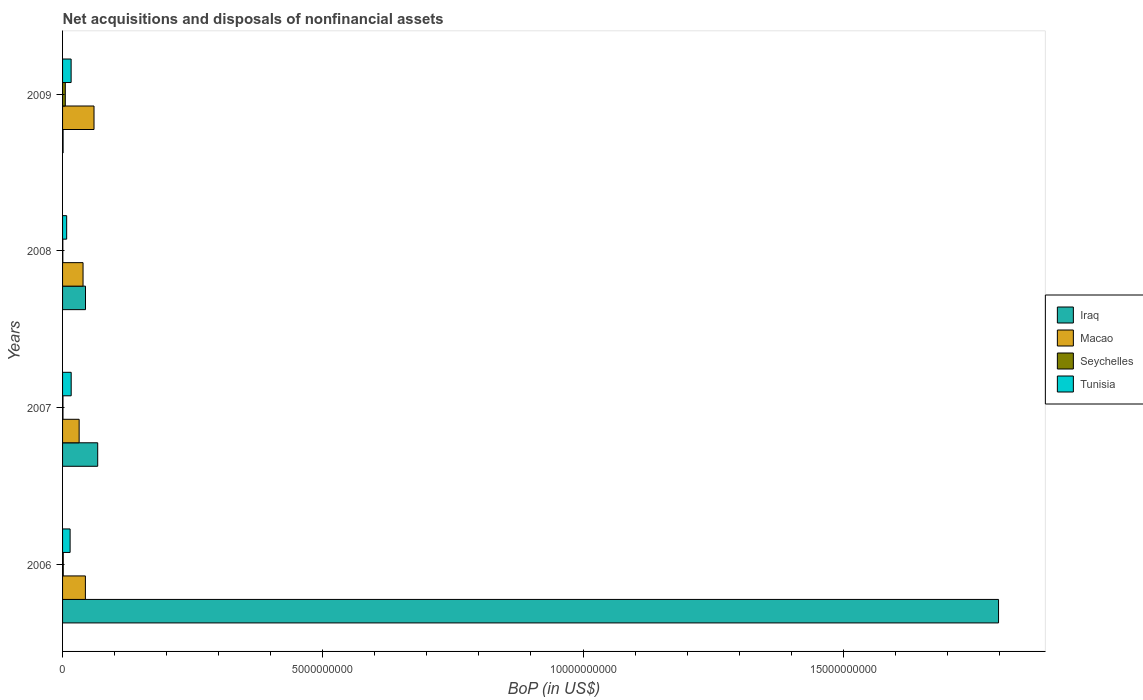Are the number of bars per tick equal to the number of legend labels?
Your response must be concise. Yes. How many bars are there on the 2nd tick from the top?
Offer a very short reply. 4. How many bars are there on the 3rd tick from the bottom?
Your answer should be very brief. 4. What is the label of the 1st group of bars from the top?
Offer a very short reply. 2009. In how many cases, is the number of bars for a given year not equal to the number of legend labels?
Provide a short and direct response. 0. What is the Balance of Payments in Macao in 2009?
Give a very brief answer. 6.04e+08. Across all years, what is the maximum Balance of Payments in Iraq?
Keep it short and to the point. 1.80e+1. Across all years, what is the minimum Balance of Payments in Iraq?
Your answer should be very brief. 1.02e+07. In which year was the Balance of Payments in Macao maximum?
Your answer should be very brief. 2009. In which year was the Balance of Payments in Iraq minimum?
Offer a terse response. 2009. What is the total Balance of Payments in Tunisia in the graph?
Offer a terse response. 5.54e+08. What is the difference between the Balance of Payments in Iraq in 2007 and that in 2009?
Make the answer very short. 6.65e+08. What is the difference between the Balance of Payments in Tunisia in 2009 and the Balance of Payments in Seychelles in 2008?
Offer a very short reply. 1.59e+08. What is the average Balance of Payments in Iraq per year?
Give a very brief answer. 4.78e+09. In the year 2006, what is the difference between the Balance of Payments in Seychelles and Balance of Payments in Iraq?
Make the answer very short. -1.80e+1. In how many years, is the Balance of Payments in Tunisia greater than 11000000000 US$?
Your answer should be compact. 0. What is the ratio of the Balance of Payments in Macao in 2006 to that in 2007?
Keep it short and to the point. 1.38. Is the difference between the Balance of Payments in Seychelles in 2008 and 2009 greater than the difference between the Balance of Payments in Iraq in 2008 and 2009?
Offer a very short reply. No. What is the difference between the highest and the second highest Balance of Payments in Macao?
Keep it short and to the point. 1.66e+08. What is the difference between the highest and the lowest Balance of Payments in Macao?
Your answer should be very brief. 2.86e+08. Is it the case that in every year, the sum of the Balance of Payments in Seychelles and Balance of Payments in Tunisia is greater than the sum of Balance of Payments in Macao and Balance of Payments in Iraq?
Offer a very short reply. No. What does the 3rd bar from the top in 2007 represents?
Offer a terse response. Macao. What does the 3rd bar from the bottom in 2007 represents?
Ensure brevity in your answer.  Seychelles. Is it the case that in every year, the sum of the Balance of Payments in Seychelles and Balance of Payments in Tunisia is greater than the Balance of Payments in Iraq?
Give a very brief answer. No. Are all the bars in the graph horizontal?
Your response must be concise. Yes. What is the difference between two consecutive major ticks on the X-axis?
Offer a very short reply. 5.00e+09. Does the graph contain grids?
Ensure brevity in your answer.  No. Where does the legend appear in the graph?
Your answer should be compact. Center right. How many legend labels are there?
Make the answer very short. 4. How are the legend labels stacked?
Give a very brief answer. Vertical. What is the title of the graph?
Give a very brief answer. Net acquisitions and disposals of nonfinancial assets. What is the label or title of the X-axis?
Keep it short and to the point. BoP (in US$). What is the label or title of the Y-axis?
Offer a very short reply. Years. What is the BoP (in US$) of Iraq in 2006?
Your response must be concise. 1.80e+1. What is the BoP (in US$) in Macao in 2006?
Offer a very short reply. 4.38e+08. What is the BoP (in US$) of Seychelles in 2006?
Ensure brevity in your answer.  1.32e+07. What is the BoP (in US$) of Tunisia in 2006?
Make the answer very short. 1.45e+08. What is the BoP (in US$) of Iraq in 2007?
Provide a succinct answer. 6.75e+08. What is the BoP (in US$) of Macao in 2007?
Offer a terse response. 3.19e+08. What is the BoP (in US$) in Seychelles in 2007?
Give a very brief answer. 8.17e+06. What is the BoP (in US$) in Tunisia in 2007?
Your answer should be compact. 1.66e+08. What is the BoP (in US$) of Iraq in 2008?
Give a very brief answer. 4.41e+08. What is the BoP (in US$) of Macao in 2008?
Provide a succinct answer. 3.93e+08. What is the BoP (in US$) of Seychelles in 2008?
Your answer should be compact. 5.04e+06. What is the BoP (in US$) in Tunisia in 2008?
Your response must be concise. 7.89e+07. What is the BoP (in US$) in Iraq in 2009?
Provide a short and direct response. 1.02e+07. What is the BoP (in US$) of Macao in 2009?
Your answer should be very brief. 6.04e+08. What is the BoP (in US$) in Seychelles in 2009?
Provide a succinct answer. 5.25e+07. What is the BoP (in US$) in Tunisia in 2009?
Your response must be concise. 1.64e+08. Across all years, what is the maximum BoP (in US$) in Iraq?
Offer a terse response. 1.80e+1. Across all years, what is the maximum BoP (in US$) in Macao?
Your answer should be compact. 6.04e+08. Across all years, what is the maximum BoP (in US$) in Seychelles?
Your answer should be compact. 5.25e+07. Across all years, what is the maximum BoP (in US$) in Tunisia?
Provide a short and direct response. 1.66e+08. Across all years, what is the minimum BoP (in US$) in Iraq?
Your response must be concise. 1.02e+07. Across all years, what is the minimum BoP (in US$) in Macao?
Offer a very short reply. 3.19e+08. Across all years, what is the minimum BoP (in US$) of Seychelles?
Offer a terse response. 5.04e+06. Across all years, what is the minimum BoP (in US$) in Tunisia?
Offer a very short reply. 7.89e+07. What is the total BoP (in US$) of Iraq in the graph?
Make the answer very short. 1.91e+1. What is the total BoP (in US$) in Macao in the graph?
Keep it short and to the point. 1.75e+09. What is the total BoP (in US$) of Seychelles in the graph?
Your answer should be compact. 7.89e+07. What is the total BoP (in US$) of Tunisia in the graph?
Offer a terse response. 5.54e+08. What is the difference between the BoP (in US$) in Iraq in 2006 and that in 2007?
Ensure brevity in your answer.  1.73e+1. What is the difference between the BoP (in US$) in Macao in 2006 and that in 2007?
Provide a short and direct response. 1.20e+08. What is the difference between the BoP (in US$) in Seychelles in 2006 and that in 2007?
Offer a very short reply. 5.07e+06. What is the difference between the BoP (in US$) in Tunisia in 2006 and that in 2007?
Your answer should be very brief. -2.06e+07. What is the difference between the BoP (in US$) of Iraq in 2006 and that in 2008?
Your answer should be very brief. 1.75e+1. What is the difference between the BoP (in US$) in Macao in 2006 and that in 2008?
Your answer should be very brief. 4.50e+07. What is the difference between the BoP (in US$) in Seychelles in 2006 and that in 2008?
Your answer should be very brief. 8.20e+06. What is the difference between the BoP (in US$) in Tunisia in 2006 and that in 2008?
Your answer should be compact. 6.60e+07. What is the difference between the BoP (in US$) in Iraq in 2006 and that in 2009?
Your response must be concise. 1.80e+1. What is the difference between the BoP (in US$) of Macao in 2006 and that in 2009?
Provide a short and direct response. -1.66e+08. What is the difference between the BoP (in US$) in Seychelles in 2006 and that in 2009?
Make the answer very short. -3.92e+07. What is the difference between the BoP (in US$) of Tunisia in 2006 and that in 2009?
Your response must be concise. -1.96e+07. What is the difference between the BoP (in US$) of Iraq in 2007 and that in 2008?
Ensure brevity in your answer.  2.34e+08. What is the difference between the BoP (in US$) of Macao in 2007 and that in 2008?
Your response must be concise. -7.49e+07. What is the difference between the BoP (in US$) in Seychelles in 2007 and that in 2008?
Offer a terse response. 3.13e+06. What is the difference between the BoP (in US$) of Tunisia in 2007 and that in 2008?
Your answer should be very brief. 8.66e+07. What is the difference between the BoP (in US$) in Iraq in 2007 and that in 2009?
Keep it short and to the point. 6.65e+08. What is the difference between the BoP (in US$) of Macao in 2007 and that in 2009?
Provide a short and direct response. -2.86e+08. What is the difference between the BoP (in US$) of Seychelles in 2007 and that in 2009?
Your answer should be compact. -4.43e+07. What is the difference between the BoP (in US$) of Tunisia in 2007 and that in 2009?
Offer a very short reply. 1.04e+06. What is the difference between the BoP (in US$) in Iraq in 2008 and that in 2009?
Ensure brevity in your answer.  4.31e+08. What is the difference between the BoP (in US$) in Macao in 2008 and that in 2009?
Keep it short and to the point. -2.11e+08. What is the difference between the BoP (in US$) of Seychelles in 2008 and that in 2009?
Provide a succinct answer. -4.74e+07. What is the difference between the BoP (in US$) of Tunisia in 2008 and that in 2009?
Your response must be concise. -8.56e+07. What is the difference between the BoP (in US$) of Iraq in 2006 and the BoP (in US$) of Macao in 2007?
Offer a terse response. 1.77e+1. What is the difference between the BoP (in US$) in Iraq in 2006 and the BoP (in US$) in Seychelles in 2007?
Your answer should be compact. 1.80e+1. What is the difference between the BoP (in US$) in Iraq in 2006 and the BoP (in US$) in Tunisia in 2007?
Offer a very short reply. 1.78e+1. What is the difference between the BoP (in US$) in Macao in 2006 and the BoP (in US$) in Seychelles in 2007?
Your response must be concise. 4.30e+08. What is the difference between the BoP (in US$) of Macao in 2006 and the BoP (in US$) of Tunisia in 2007?
Keep it short and to the point. 2.73e+08. What is the difference between the BoP (in US$) of Seychelles in 2006 and the BoP (in US$) of Tunisia in 2007?
Offer a very short reply. -1.52e+08. What is the difference between the BoP (in US$) of Iraq in 2006 and the BoP (in US$) of Macao in 2008?
Make the answer very short. 1.76e+1. What is the difference between the BoP (in US$) in Iraq in 2006 and the BoP (in US$) in Seychelles in 2008?
Your answer should be very brief. 1.80e+1. What is the difference between the BoP (in US$) of Iraq in 2006 and the BoP (in US$) of Tunisia in 2008?
Provide a succinct answer. 1.79e+1. What is the difference between the BoP (in US$) in Macao in 2006 and the BoP (in US$) in Seychelles in 2008?
Give a very brief answer. 4.33e+08. What is the difference between the BoP (in US$) in Macao in 2006 and the BoP (in US$) in Tunisia in 2008?
Provide a succinct answer. 3.60e+08. What is the difference between the BoP (in US$) of Seychelles in 2006 and the BoP (in US$) of Tunisia in 2008?
Give a very brief answer. -6.56e+07. What is the difference between the BoP (in US$) of Iraq in 2006 and the BoP (in US$) of Macao in 2009?
Offer a terse response. 1.74e+1. What is the difference between the BoP (in US$) of Iraq in 2006 and the BoP (in US$) of Seychelles in 2009?
Keep it short and to the point. 1.79e+1. What is the difference between the BoP (in US$) of Iraq in 2006 and the BoP (in US$) of Tunisia in 2009?
Offer a terse response. 1.78e+1. What is the difference between the BoP (in US$) of Macao in 2006 and the BoP (in US$) of Seychelles in 2009?
Your answer should be compact. 3.86e+08. What is the difference between the BoP (in US$) in Macao in 2006 and the BoP (in US$) in Tunisia in 2009?
Make the answer very short. 2.74e+08. What is the difference between the BoP (in US$) in Seychelles in 2006 and the BoP (in US$) in Tunisia in 2009?
Your answer should be compact. -1.51e+08. What is the difference between the BoP (in US$) of Iraq in 2007 and the BoP (in US$) of Macao in 2008?
Offer a very short reply. 2.82e+08. What is the difference between the BoP (in US$) of Iraq in 2007 and the BoP (in US$) of Seychelles in 2008?
Your answer should be very brief. 6.70e+08. What is the difference between the BoP (in US$) in Iraq in 2007 and the BoP (in US$) in Tunisia in 2008?
Your answer should be compact. 5.96e+08. What is the difference between the BoP (in US$) of Macao in 2007 and the BoP (in US$) of Seychelles in 2008?
Make the answer very short. 3.14e+08. What is the difference between the BoP (in US$) in Macao in 2007 and the BoP (in US$) in Tunisia in 2008?
Provide a succinct answer. 2.40e+08. What is the difference between the BoP (in US$) of Seychelles in 2007 and the BoP (in US$) of Tunisia in 2008?
Make the answer very short. -7.07e+07. What is the difference between the BoP (in US$) in Iraq in 2007 and the BoP (in US$) in Macao in 2009?
Offer a very short reply. 7.09e+07. What is the difference between the BoP (in US$) in Iraq in 2007 and the BoP (in US$) in Seychelles in 2009?
Your response must be concise. 6.23e+08. What is the difference between the BoP (in US$) in Iraq in 2007 and the BoP (in US$) in Tunisia in 2009?
Offer a very short reply. 5.11e+08. What is the difference between the BoP (in US$) of Macao in 2007 and the BoP (in US$) of Seychelles in 2009?
Your response must be concise. 2.66e+08. What is the difference between the BoP (in US$) in Macao in 2007 and the BoP (in US$) in Tunisia in 2009?
Keep it short and to the point. 1.54e+08. What is the difference between the BoP (in US$) in Seychelles in 2007 and the BoP (in US$) in Tunisia in 2009?
Ensure brevity in your answer.  -1.56e+08. What is the difference between the BoP (in US$) in Iraq in 2008 and the BoP (in US$) in Macao in 2009?
Offer a very short reply. -1.63e+08. What is the difference between the BoP (in US$) of Iraq in 2008 and the BoP (in US$) of Seychelles in 2009?
Give a very brief answer. 3.88e+08. What is the difference between the BoP (in US$) of Iraq in 2008 and the BoP (in US$) of Tunisia in 2009?
Provide a succinct answer. 2.76e+08. What is the difference between the BoP (in US$) of Macao in 2008 and the BoP (in US$) of Seychelles in 2009?
Your response must be concise. 3.41e+08. What is the difference between the BoP (in US$) in Macao in 2008 and the BoP (in US$) in Tunisia in 2009?
Give a very brief answer. 2.29e+08. What is the difference between the BoP (in US$) in Seychelles in 2008 and the BoP (in US$) in Tunisia in 2009?
Ensure brevity in your answer.  -1.59e+08. What is the average BoP (in US$) in Iraq per year?
Keep it short and to the point. 4.78e+09. What is the average BoP (in US$) in Macao per year?
Ensure brevity in your answer.  4.39e+08. What is the average BoP (in US$) in Seychelles per year?
Provide a short and direct response. 1.97e+07. What is the average BoP (in US$) of Tunisia per year?
Your answer should be compact. 1.38e+08. In the year 2006, what is the difference between the BoP (in US$) in Iraq and BoP (in US$) in Macao?
Provide a succinct answer. 1.75e+1. In the year 2006, what is the difference between the BoP (in US$) of Iraq and BoP (in US$) of Seychelles?
Your response must be concise. 1.80e+1. In the year 2006, what is the difference between the BoP (in US$) in Iraq and BoP (in US$) in Tunisia?
Your response must be concise. 1.78e+1. In the year 2006, what is the difference between the BoP (in US$) of Macao and BoP (in US$) of Seychelles?
Your response must be concise. 4.25e+08. In the year 2006, what is the difference between the BoP (in US$) of Macao and BoP (in US$) of Tunisia?
Provide a succinct answer. 2.94e+08. In the year 2006, what is the difference between the BoP (in US$) of Seychelles and BoP (in US$) of Tunisia?
Make the answer very short. -1.32e+08. In the year 2007, what is the difference between the BoP (in US$) in Iraq and BoP (in US$) in Macao?
Keep it short and to the point. 3.56e+08. In the year 2007, what is the difference between the BoP (in US$) of Iraq and BoP (in US$) of Seychelles?
Your answer should be very brief. 6.67e+08. In the year 2007, what is the difference between the BoP (in US$) of Iraq and BoP (in US$) of Tunisia?
Ensure brevity in your answer.  5.10e+08. In the year 2007, what is the difference between the BoP (in US$) of Macao and BoP (in US$) of Seychelles?
Your response must be concise. 3.10e+08. In the year 2007, what is the difference between the BoP (in US$) in Macao and BoP (in US$) in Tunisia?
Your response must be concise. 1.53e+08. In the year 2007, what is the difference between the BoP (in US$) in Seychelles and BoP (in US$) in Tunisia?
Make the answer very short. -1.57e+08. In the year 2008, what is the difference between the BoP (in US$) in Iraq and BoP (in US$) in Macao?
Your answer should be compact. 4.73e+07. In the year 2008, what is the difference between the BoP (in US$) of Iraq and BoP (in US$) of Seychelles?
Keep it short and to the point. 4.36e+08. In the year 2008, what is the difference between the BoP (in US$) of Iraq and BoP (in US$) of Tunisia?
Make the answer very short. 3.62e+08. In the year 2008, what is the difference between the BoP (in US$) of Macao and BoP (in US$) of Seychelles?
Your answer should be very brief. 3.88e+08. In the year 2008, what is the difference between the BoP (in US$) in Macao and BoP (in US$) in Tunisia?
Keep it short and to the point. 3.15e+08. In the year 2008, what is the difference between the BoP (in US$) in Seychelles and BoP (in US$) in Tunisia?
Your answer should be compact. -7.38e+07. In the year 2009, what is the difference between the BoP (in US$) in Iraq and BoP (in US$) in Macao?
Provide a succinct answer. -5.94e+08. In the year 2009, what is the difference between the BoP (in US$) in Iraq and BoP (in US$) in Seychelles?
Make the answer very short. -4.23e+07. In the year 2009, what is the difference between the BoP (in US$) in Iraq and BoP (in US$) in Tunisia?
Provide a succinct answer. -1.54e+08. In the year 2009, what is the difference between the BoP (in US$) of Macao and BoP (in US$) of Seychelles?
Your answer should be compact. 5.52e+08. In the year 2009, what is the difference between the BoP (in US$) of Macao and BoP (in US$) of Tunisia?
Provide a succinct answer. 4.40e+08. In the year 2009, what is the difference between the BoP (in US$) of Seychelles and BoP (in US$) of Tunisia?
Your response must be concise. -1.12e+08. What is the ratio of the BoP (in US$) of Iraq in 2006 to that in 2007?
Provide a succinct answer. 26.64. What is the ratio of the BoP (in US$) in Macao in 2006 to that in 2007?
Your answer should be very brief. 1.38. What is the ratio of the BoP (in US$) of Seychelles in 2006 to that in 2007?
Keep it short and to the point. 1.62. What is the ratio of the BoP (in US$) in Tunisia in 2006 to that in 2007?
Provide a succinct answer. 0.88. What is the ratio of the BoP (in US$) of Iraq in 2006 to that in 2008?
Make the answer very short. 40.8. What is the ratio of the BoP (in US$) of Macao in 2006 to that in 2008?
Provide a succinct answer. 1.11. What is the ratio of the BoP (in US$) of Seychelles in 2006 to that in 2008?
Provide a short and direct response. 2.63. What is the ratio of the BoP (in US$) in Tunisia in 2006 to that in 2008?
Provide a succinct answer. 1.84. What is the ratio of the BoP (in US$) in Iraq in 2006 to that in 2009?
Provide a short and direct response. 1763.14. What is the ratio of the BoP (in US$) of Macao in 2006 to that in 2009?
Provide a short and direct response. 0.73. What is the ratio of the BoP (in US$) of Seychelles in 2006 to that in 2009?
Make the answer very short. 0.25. What is the ratio of the BoP (in US$) of Tunisia in 2006 to that in 2009?
Make the answer very short. 0.88. What is the ratio of the BoP (in US$) of Iraq in 2007 to that in 2008?
Your answer should be compact. 1.53. What is the ratio of the BoP (in US$) of Macao in 2007 to that in 2008?
Your response must be concise. 0.81. What is the ratio of the BoP (in US$) in Seychelles in 2007 to that in 2008?
Ensure brevity in your answer.  1.62. What is the ratio of the BoP (in US$) of Tunisia in 2007 to that in 2008?
Offer a terse response. 2.1. What is the ratio of the BoP (in US$) in Iraq in 2007 to that in 2009?
Your answer should be very brief. 66.19. What is the ratio of the BoP (in US$) of Macao in 2007 to that in 2009?
Your answer should be very brief. 0.53. What is the ratio of the BoP (in US$) of Seychelles in 2007 to that in 2009?
Provide a short and direct response. 0.16. What is the ratio of the BoP (in US$) of Tunisia in 2007 to that in 2009?
Give a very brief answer. 1.01. What is the ratio of the BoP (in US$) in Iraq in 2008 to that in 2009?
Your response must be concise. 43.22. What is the ratio of the BoP (in US$) in Macao in 2008 to that in 2009?
Your response must be concise. 0.65. What is the ratio of the BoP (in US$) of Seychelles in 2008 to that in 2009?
Make the answer very short. 0.1. What is the ratio of the BoP (in US$) in Tunisia in 2008 to that in 2009?
Keep it short and to the point. 0.48. What is the difference between the highest and the second highest BoP (in US$) in Iraq?
Ensure brevity in your answer.  1.73e+1. What is the difference between the highest and the second highest BoP (in US$) in Macao?
Offer a very short reply. 1.66e+08. What is the difference between the highest and the second highest BoP (in US$) of Seychelles?
Provide a succinct answer. 3.92e+07. What is the difference between the highest and the second highest BoP (in US$) of Tunisia?
Give a very brief answer. 1.04e+06. What is the difference between the highest and the lowest BoP (in US$) of Iraq?
Provide a short and direct response. 1.80e+1. What is the difference between the highest and the lowest BoP (in US$) of Macao?
Your response must be concise. 2.86e+08. What is the difference between the highest and the lowest BoP (in US$) in Seychelles?
Offer a terse response. 4.74e+07. What is the difference between the highest and the lowest BoP (in US$) in Tunisia?
Give a very brief answer. 8.66e+07. 